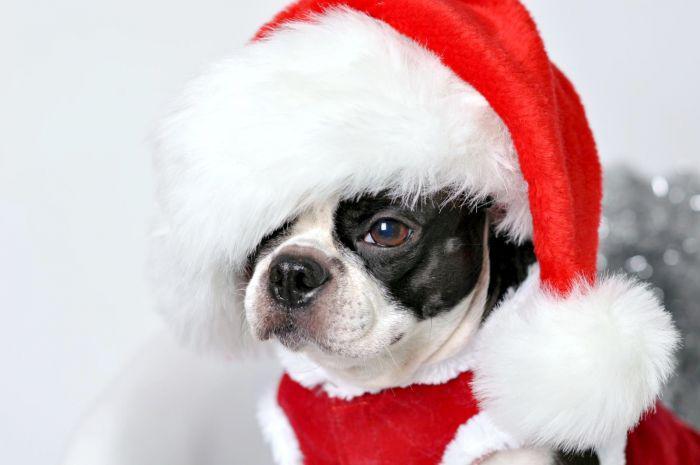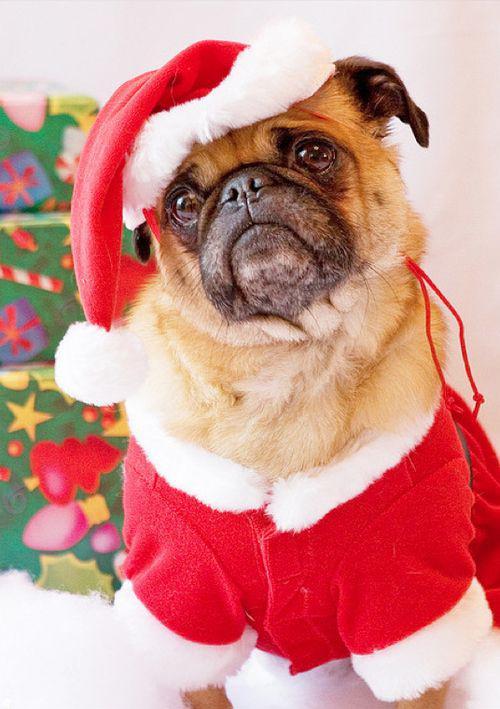The first image is the image on the left, the second image is the image on the right. Considering the images on both sides, is "The combined images include two dogs wearing Santa outfits, including red hats with white pom-poms." valid? Answer yes or no. Yes. The first image is the image on the left, the second image is the image on the right. Considering the images on both sides, is "There are exactly four dogs in total." valid? Answer yes or no. No. 